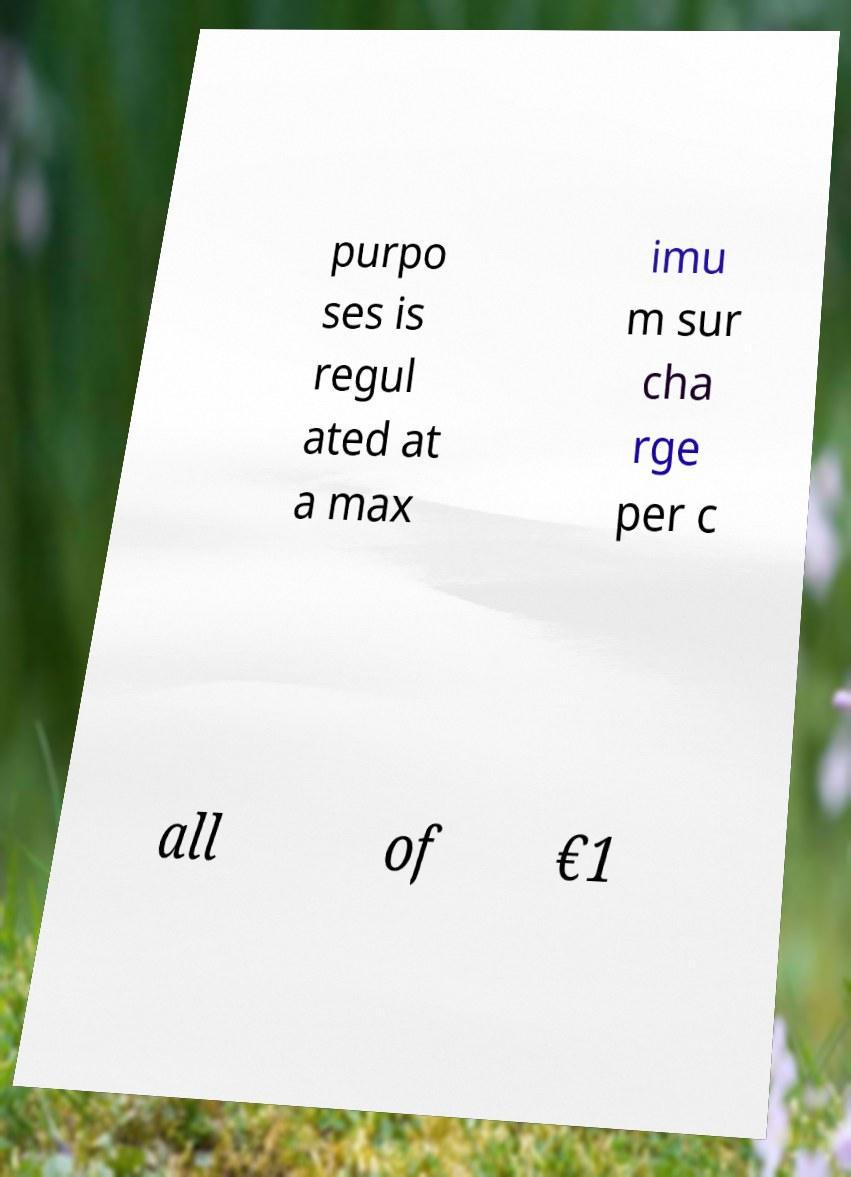Can you accurately transcribe the text from the provided image for me? purpo ses is regul ated at a max imu m sur cha rge per c all of €1 